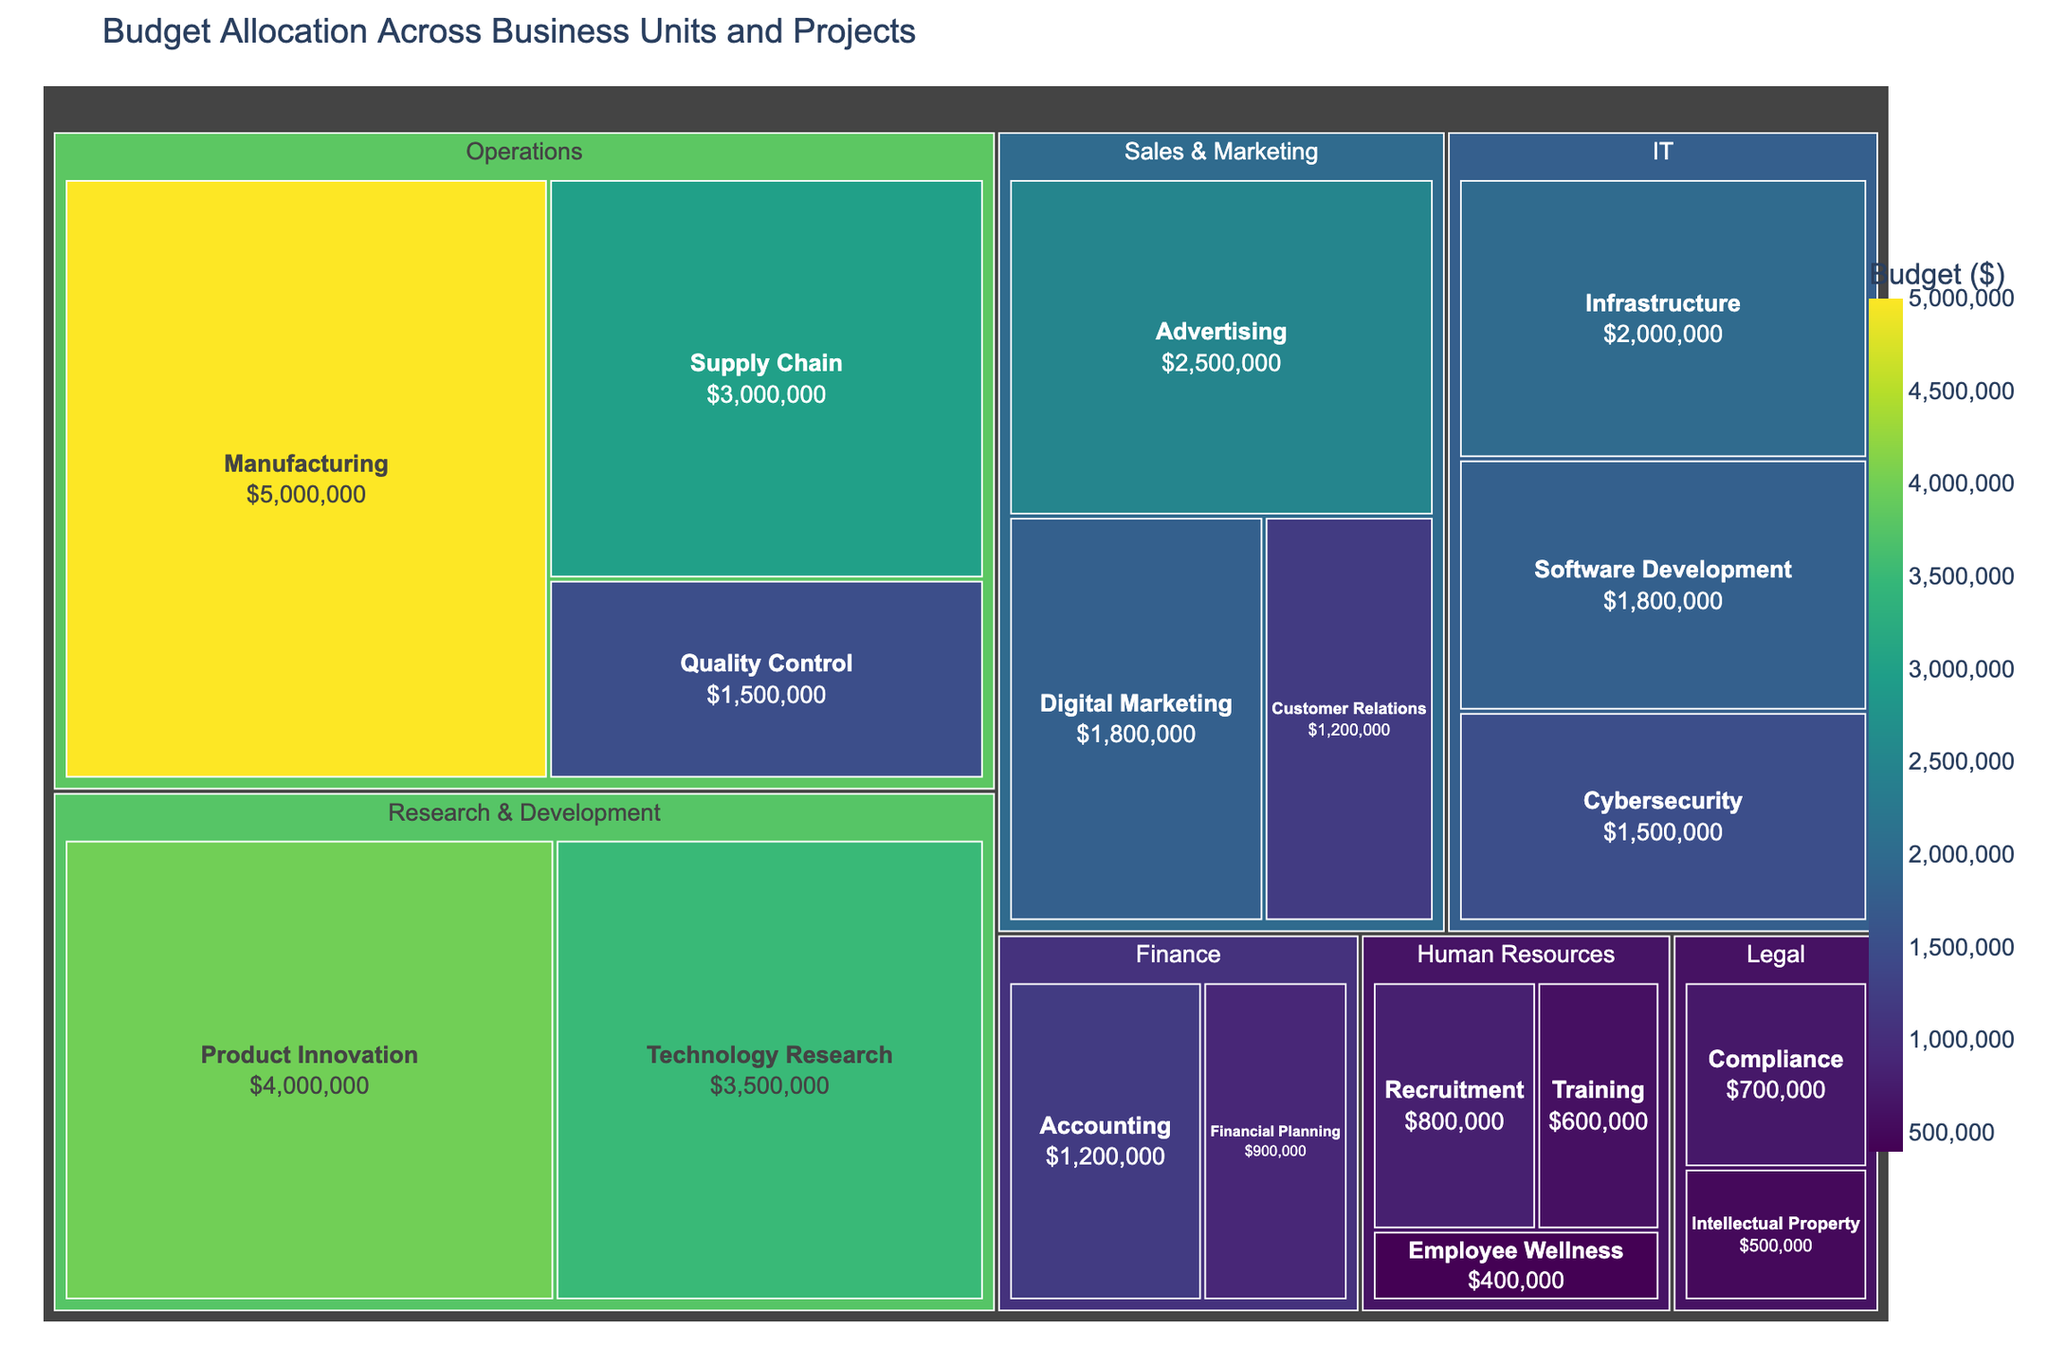What is the title of the treemap? The title is displayed at the top of the figure and is typically larger than other text.
Answer: Budget Allocation Across Business Units and Projects Which subcategory in Operations has the highest budget allocation? Locate the Operations category and identify the subcategory with the largest segment.
Answer: Manufacturing What is the total budget allocated to Sales & Marketing? Sum the values of the subcategories under Sales & Marketing: Advertising ($2,500,000), Digital Marketing ($1,800,000), Customer Relations ($1,200,000).
Answer: $5,500,000 Compare the budget for Technology Research and Infrastructure. Which one is higher? Locate the subcategories Technology Research and Infrastructure, check their budget values and compare them.
Answer: Technology Research How much more budget is allocated to Manufacturing than to Advertising? Subtract the budget of Advertising ($2,500,000) from Manufacturing ($5,000,000).
Answer: $2,500,000 What is the color scheme used for the budget values in the treemap? Observe the color gradient in the legend provided to understand the scheme applied.
Answer: Viridis Which business unit has the smallest budget allocation? Identify the smallest segment in the entire treemap.
Answer: Legal What is the combined budget for IT and Finance? Sum the budget for all subcategories in IT ($2,000,000 + $1,500,000 + $1,800,000) and Finance ($1,200,000 + $900,000).
Answer: $7,400,000 Among the Human Resources subcategories, which one has the lowest budget? Locate the subcategories under Human Resources and identify the smallest segment.
Answer: Employee Wellness Is the budget allocation for Compliance greater than for Employee Wellness? Compare the budget values for Compliance ($700,000) and Employee Wellness ($400,000).
Answer: Yes 